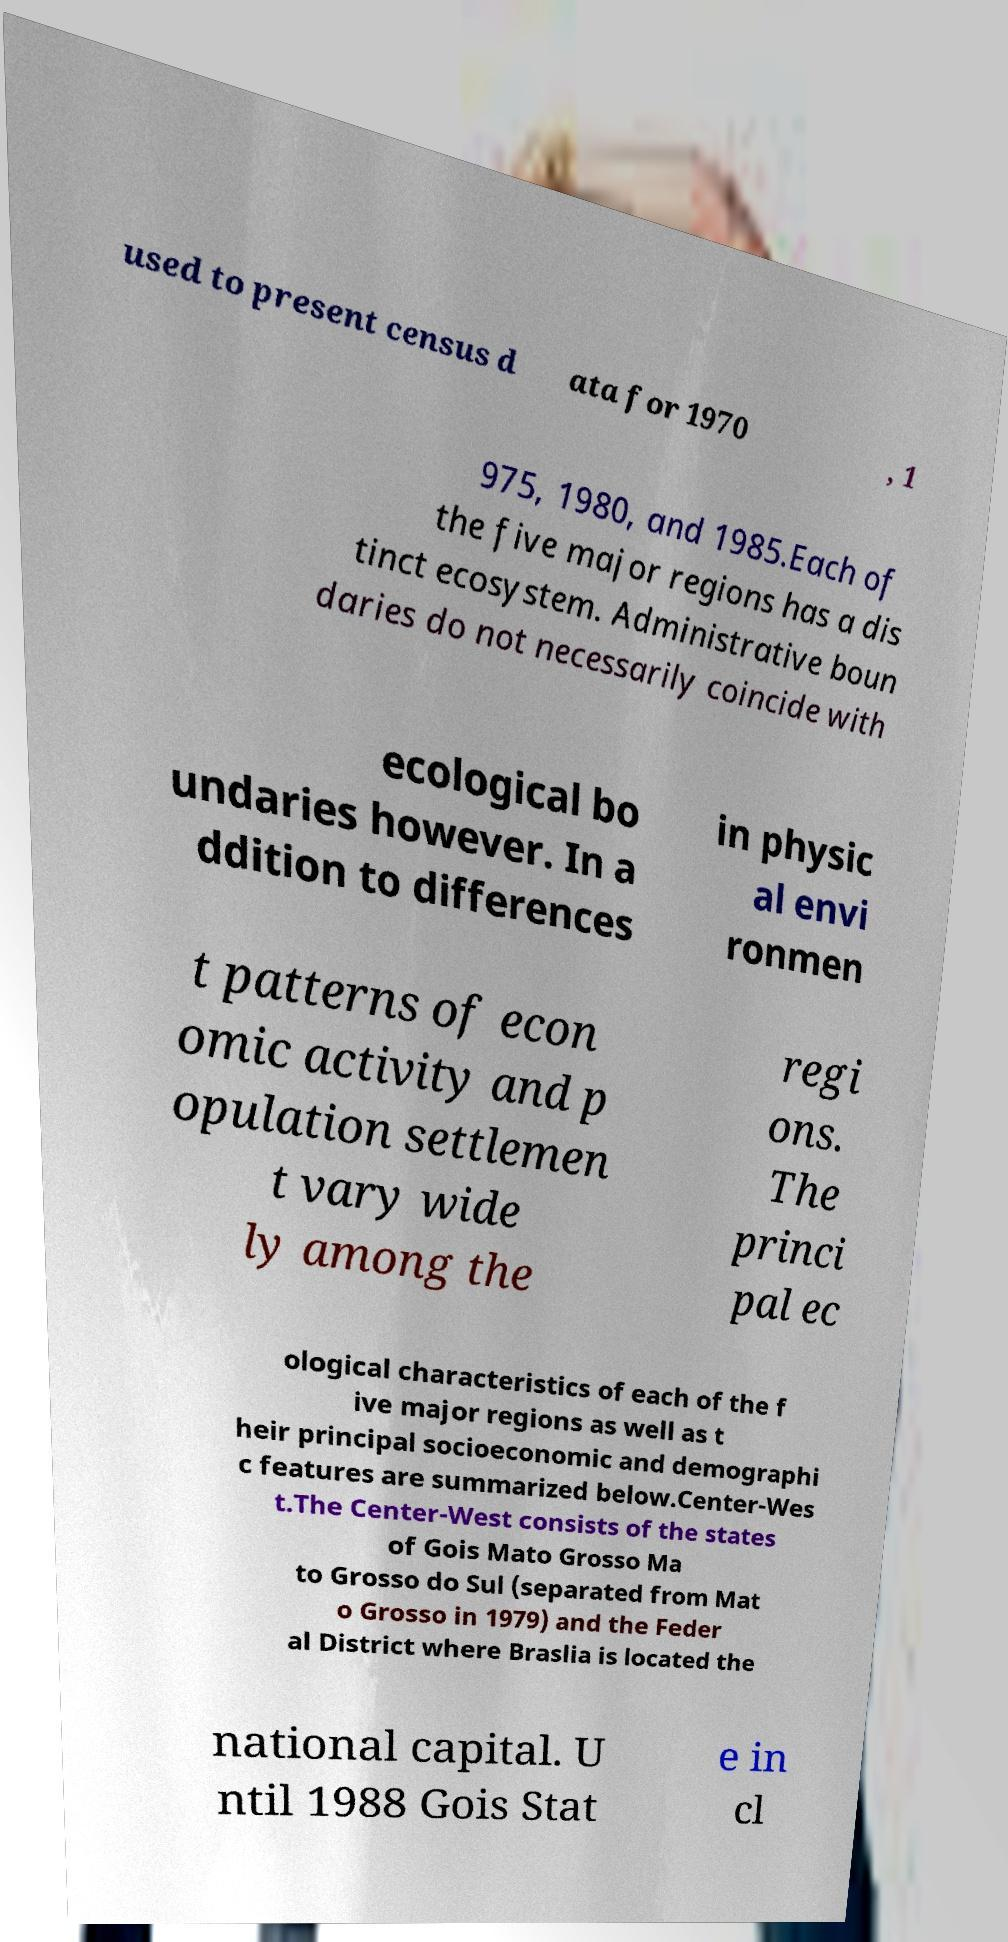I need the written content from this picture converted into text. Can you do that? used to present census d ata for 1970 , 1 975, 1980, and 1985.Each of the five major regions has a dis tinct ecosystem. Administrative boun daries do not necessarily coincide with ecological bo undaries however. In a ddition to differences in physic al envi ronmen t patterns of econ omic activity and p opulation settlemen t vary wide ly among the regi ons. The princi pal ec ological characteristics of each of the f ive major regions as well as t heir principal socioeconomic and demographi c features are summarized below.Center-Wes t.The Center-West consists of the states of Gois Mato Grosso Ma to Grosso do Sul (separated from Mat o Grosso in 1979) and the Feder al District where Braslia is located the national capital. U ntil 1988 Gois Stat e in cl 